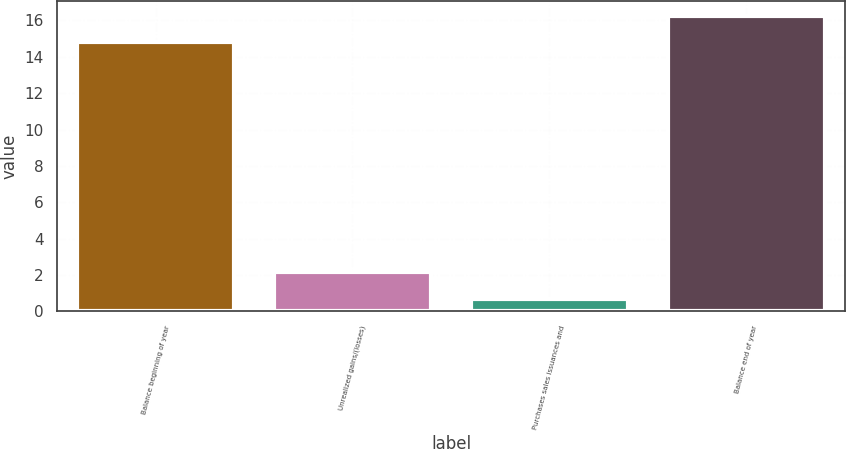<chart> <loc_0><loc_0><loc_500><loc_500><bar_chart><fcel>Balance beginning of year<fcel>Unrealized gains/(losses)<fcel>Purchases sales issuances and<fcel>Balance end of year<nl><fcel>14.8<fcel>2.15<fcel>0.7<fcel>16.25<nl></chart> 